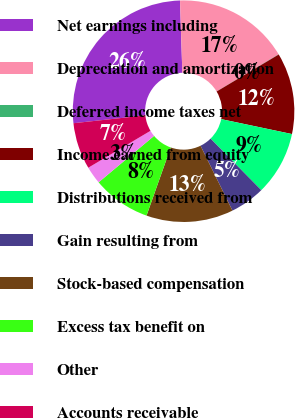Convert chart. <chart><loc_0><loc_0><loc_500><loc_500><pie_chart><fcel>Net earnings including<fcel>Depreciation and amortization<fcel>Deferred income taxes net<fcel>Income earned from equity<fcel>Distributions received from<fcel>Gain resulting from<fcel>Stock-based compensation<fcel>Excess tax benefit on<fcel>Other<fcel>Accounts receivable<nl><fcel>26.22%<fcel>16.93%<fcel>0.03%<fcel>11.86%<fcel>9.32%<fcel>5.1%<fcel>12.7%<fcel>8.48%<fcel>2.57%<fcel>6.79%<nl></chart> 